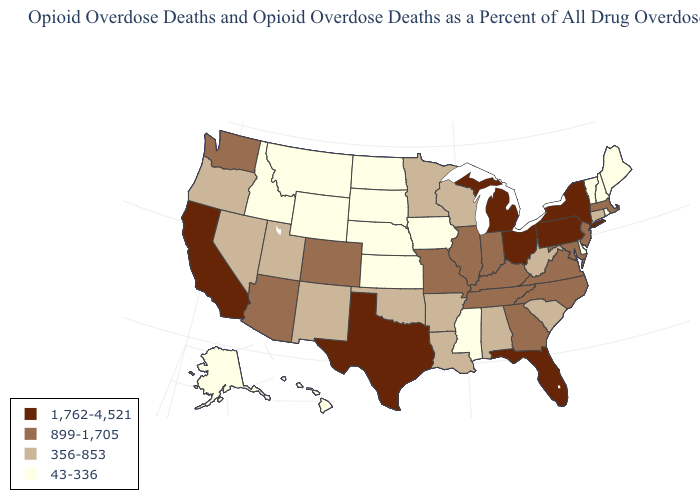Does Idaho have the lowest value in the West?
Quick response, please. Yes. Which states have the lowest value in the USA?
Be succinct. Alaska, Delaware, Hawaii, Idaho, Iowa, Kansas, Maine, Mississippi, Montana, Nebraska, New Hampshire, North Dakota, Rhode Island, South Dakota, Vermont, Wyoming. Name the states that have a value in the range 43-336?
Concise answer only. Alaska, Delaware, Hawaii, Idaho, Iowa, Kansas, Maine, Mississippi, Montana, Nebraska, New Hampshire, North Dakota, Rhode Island, South Dakota, Vermont, Wyoming. What is the lowest value in the West?
Write a very short answer. 43-336. Name the states that have a value in the range 43-336?
Quick response, please. Alaska, Delaware, Hawaii, Idaho, Iowa, Kansas, Maine, Mississippi, Montana, Nebraska, New Hampshire, North Dakota, Rhode Island, South Dakota, Vermont, Wyoming. Name the states that have a value in the range 356-853?
Be succinct. Alabama, Arkansas, Connecticut, Louisiana, Minnesota, Nevada, New Mexico, Oklahoma, Oregon, South Carolina, Utah, West Virginia, Wisconsin. Does New Jersey have the highest value in the Northeast?
Concise answer only. No. Does the map have missing data?
Concise answer only. No. Name the states that have a value in the range 356-853?
Concise answer only. Alabama, Arkansas, Connecticut, Louisiana, Minnesota, Nevada, New Mexico, Oklahoma, Oregon, South Carolina, Utah, West Virginia, Wisconsin. Among the states that border Maryland , does Virginia have the highest value?
Give a very brief answer. No. What is the value of Missouri?
Short answer required. 899-1,705. What is the value of Texas?
Answer briefly. 1,762-4,521. Name the states that have a value in the range 1,762-4,521?
Be succinct. California, Florida, Michigan, New York, Ohio, Pennsylvania, Texas. Among the states that border South Carolina , which have the lowest value?
Short answer required. Georgia, North Carolina. Name the states that have a value in the range 356-853?
Concise answer only. Alabama, Arkansas, Connecticut, Louisiana, Minnesota, Nevada, New Mexico, Oklahoma, Oregon, South Carolina, Utah, West Virginia, Wisconsin. 